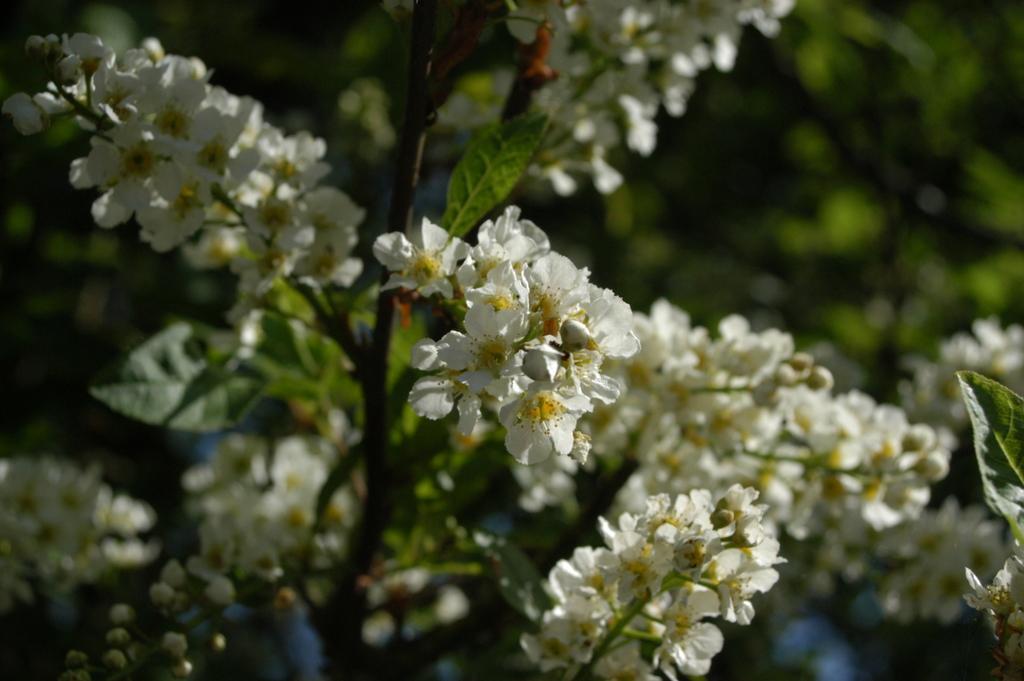Please provide a concise description of this image. In this image I can see the white and yellow color flowers to the plants. And there is a blurred background. 